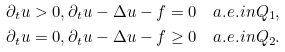<formula> <loc_0><loc_0><loc_500><loc_500>& \partial _ { t } u > 0 , \partial _ { t } u - \Delta u - f = 0 \quad a . e . i n Q _ { 1 } , \\ & \partial _ { t } u = 0 , \partial _ { t } u - \Delta u - f \geq 0 \quad a . e . i n Q _ { 2 } .</formula> 